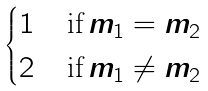Convert formula to latex. <formula><loc_0><loc_0><loc_500><loc_500>\begin{cases} 1 & \, \text {if} \, m _ { 1 } = m _ { 2 } \\ 2 & \, \text {if} \, m _ { 1 } \neq m _ { 2 } \end{cases}</formula> 